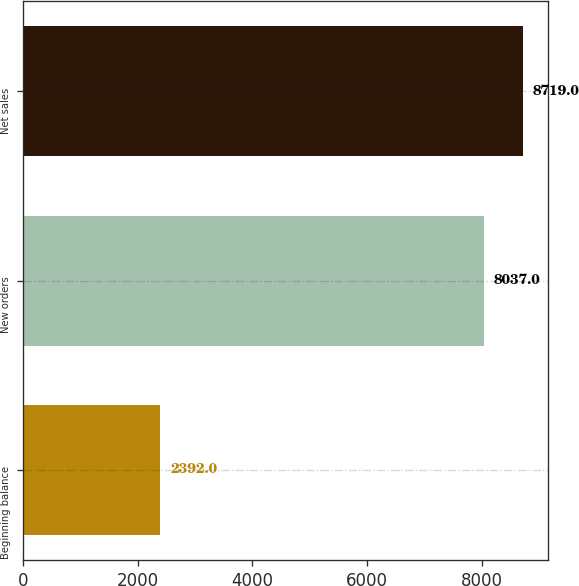Convert chart. <chart><loc_0><loc_0><loc_500><loc_500><bar_chart><fcel>Beginning balance<fcel>New orders<fcel>Net sales<nl><fcel>2392<fcel>8037<fcel>8719<nl></chart> 